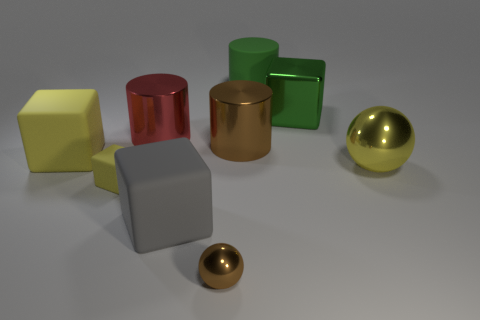Subtract all red cubes. Subtract all blue balls. How many cubes are left? 4 Add 1 balls. How many objects exist? 10 Subtract all balls. How many objects are left? 7 Add 6 large yellow things. How many large yellow things are left? 8 Add 3 small cyan rubber spheres. How many small cyan rubber spheres exist? 3 Subtract 0 red balls. How many objects are left? 9 Subtract all big blue metal balls. Subtract all green blocks. How many objects are left? 8 